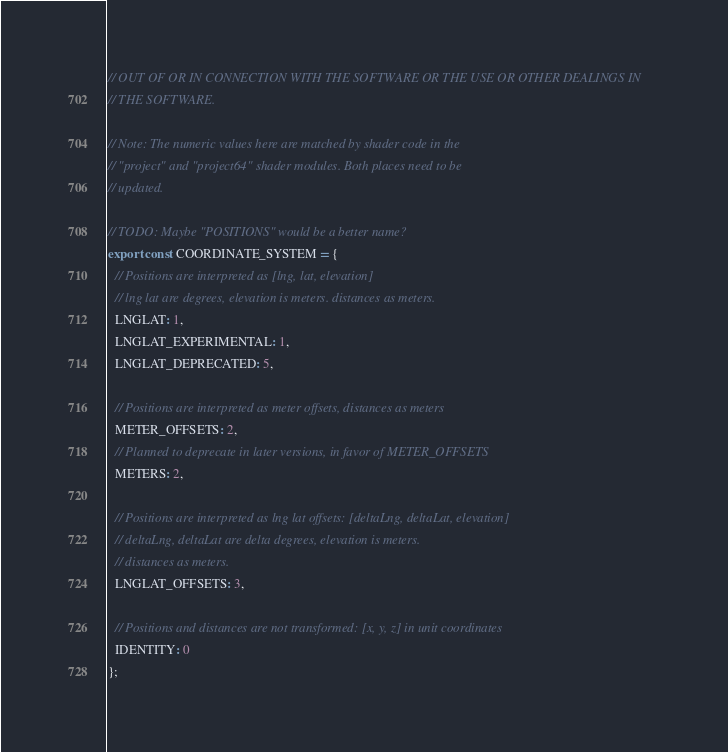<code> <loc_0><loc_0><loc_500><loc_500><_JavaScript_>// OUT OF OR IN CONNECTION WITH THE SOFTWARE OR THE USE OR OTHER DEALINGS IN
// THE SOFTWARE.

// Note: The numeric values here are matched by shader code in the
// "project" and "project64" shader modules. Both places need to be
// updated.

// TODO: Maybe "POSITIONS" would be a better name?
export const COORDINATE_SYSTEM = {
  // Positions are interpreted as [lng, lat, elevation]
  // lng lat are degrees, elevation is meters. distances as meters.
  LNGLAT: 1,
  LNGLAT_EXPERIMENTAL: 1,
  LNGLAT_DEPRECATED: 5,

  // Positions are interpreted as meter offsets, distances as meters
  METER_OFFSETS: 2,
  // Planned to deprecate in later versions, in favor of METER_OFFSETS
  METERS: 2,

  // Positions are interpreted as lng lat offsets: [deltaLng, deltaLat, elevation]
  // deltaLng, deltaLat are delta degrees, elevation is meters.
  // distances as meters.
  LNGLAT_OFFSETS: 3,

  // Positions and distances are not transformed: [x, y, z] in unit coordinates
  IDENTITY: 0
};
</code> 